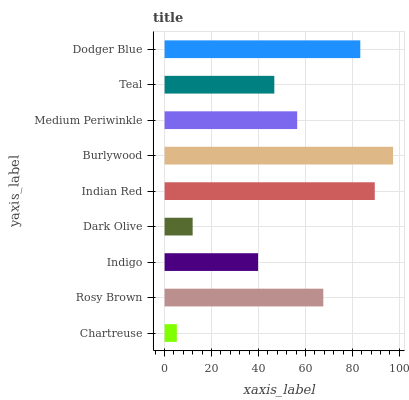Is Chartreuse the minimum?
Answer yes or no. Yes. Is Burlywood the maximum?
Answer yes or no. Yes. Is Rosy Brown the minimum?
Answer yes or no. No. Is Rosy Brown the maximum?
Answer yes or no. No. Is Rosy Brown greater than Chartreuse?
Answer yes or no. Yes. Is Chartreuse less than Rosy Brown?
Answer yes or no. Yes. Is Chartreuse greater than Rosy Brown?
Answer yes or no. No. Is Rosy Brown less than Chartreuse?
Answer yes or no. No. Is Medium Periwinkle the high median?
Answer yes or no. Yes. Is Medium Periwinkle the low median?
Answer yes or no. Yes. Is Dark Olive the high median?
Answer yes or no. No. Is Burlywood the low median?
Answer yes or no. No. 